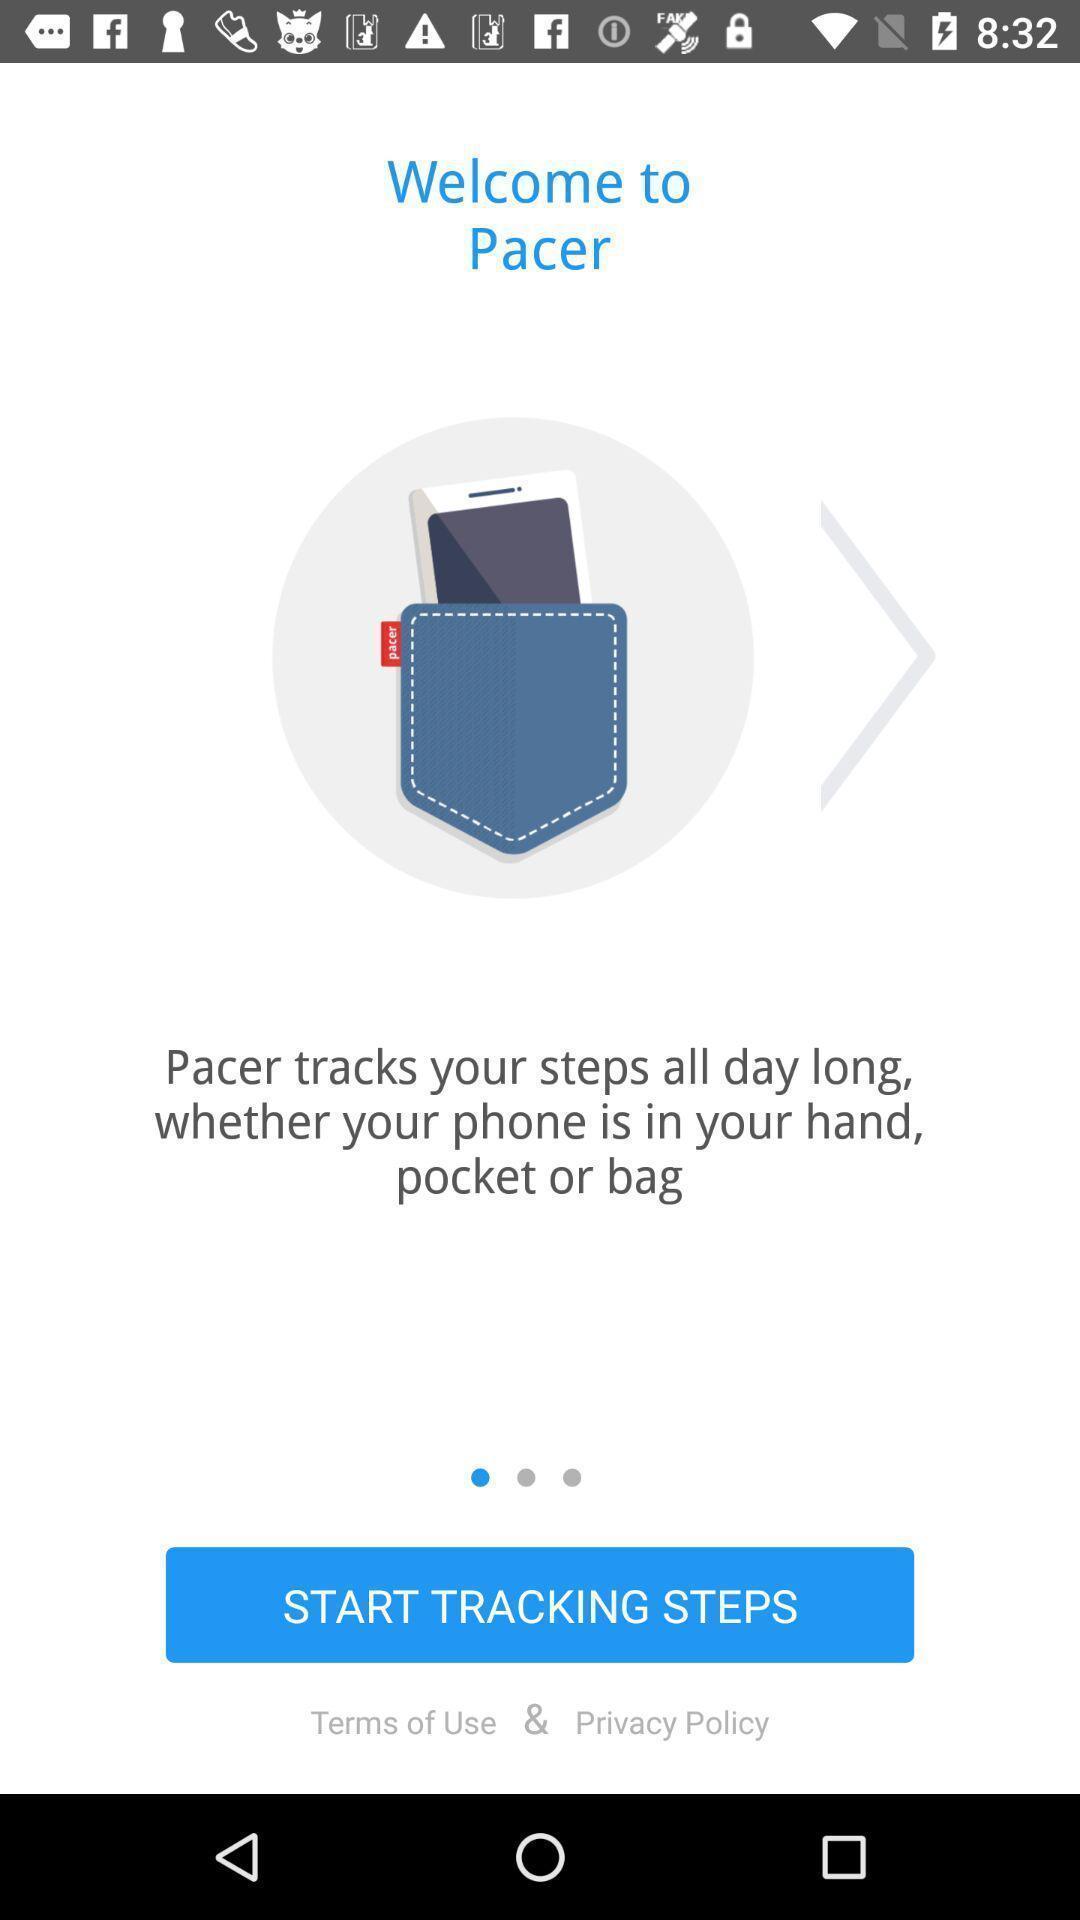Describe this image in words. Window displaying a pedometer app. 